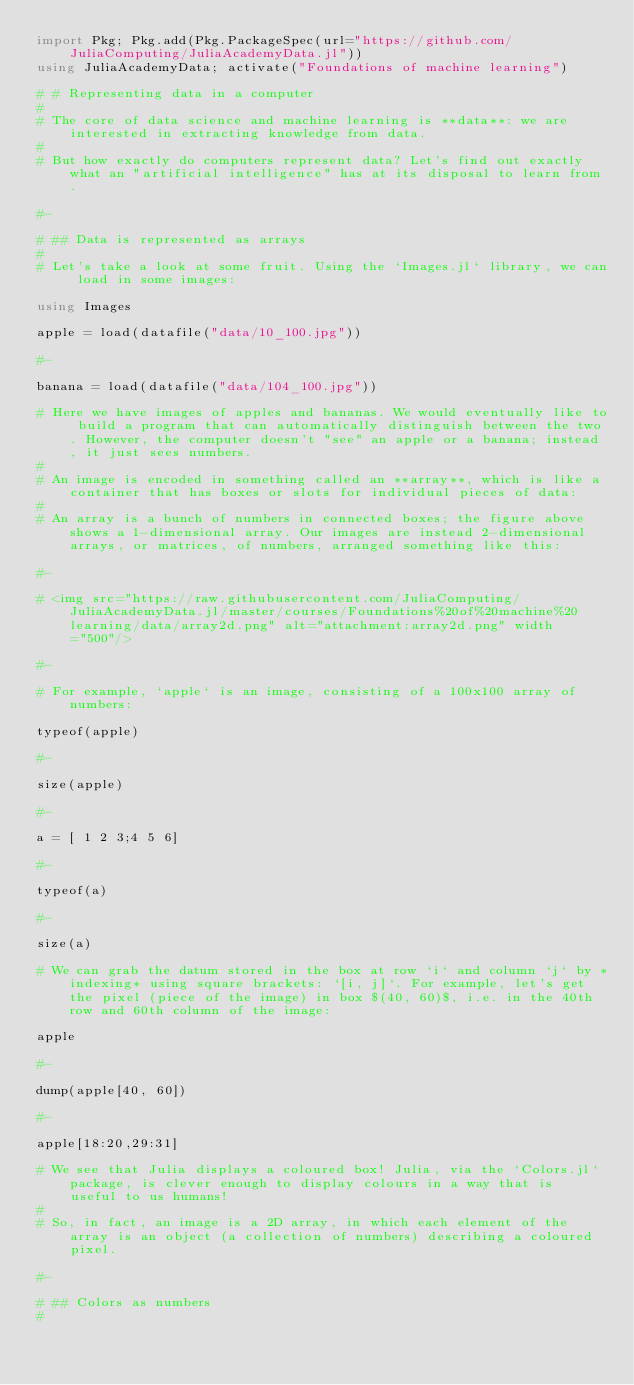<code> <loc_0><loc_0><loc_500><loc_500><_Julia_>import Pkg; Pkg.add(Pkg.PackageSpec(url="https://github.com/JuliaComputing/JuliaAcademyData.jl"))
using JuliaAcademyData; activate("Foundations of machine learning")

# # Representing data in a computer
#
# The core of data science and machine learning is **data**: we are interested in extracting knowledge from data.
#
# But how exactly do computers represent data? Let's find out exactly what an "artificial intelligence" has at its disposal to learn from.

#-

# ## Data is represented as arrays
#
# Let's take a look at some fruit. Using the `Images.jl` library, we can load in some images:

using Images

apple = load(datafile("data/10_100.jpg"))

#-

banana = load(datafile("data/104_100.jpg"))

# Here we have images of apples and bananas. We would eventually like to build a program that can automatically distinguish between the two. However, the computer doesn't "see" an apple or a banana; instead, it just sees numbers.
#
# An image is encoded in something called an **array**, which is like a container that has boxes or slots for individual pieces of data:
#
# An array is a bunch of numbers in connected boxes; the figure above shows a 1-dimensional array. Our images are instead 2-dimensional arrays, or matrices, of numbers, arranged something like this:

#-

# <img src="https://raw.githubusercontent.com/JuliaComputing/JuliaAcademyData.jl/master/courses/Foundations%20of%20machine%20learning/data/array2d.png" alt="attachment:array2d.png" width="500"/>

#-

# For example, `apple` is an image, consisting of a 100x100 array of numbers:

typeof(apple)

#-

size(apple)

#-

a = [ 1 2 3;4 5 6]

#-

typeof(a)

#-

size(a)

# We can grab the datum stored in the box at row `i` and column `j` by *indexing* using square brackets: `[i, j]`. For example, let's get the pixel (piece of the image) in box $(40, 60)$, i.e. in the 40th row and 60th column of the image:

apple

#-

dump(apple[40, 60])

#-

apple[18:20,29:31]

# We see that Julia displays a coloured box! Julia, via the `Colors.jl` package, is clever enough to display colours in a way that is useful to us humans!
#
# So, in fact, an image is a 2D array, in which each element of the array is an object (a collection of numbers) describing a coloured pixel.

#-

# ## Colors as numbers
#</code> 